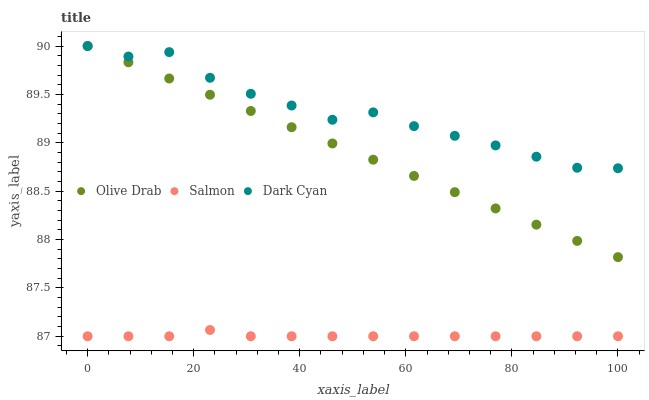Does Salmon have the minimum area under the curve?
Answer yes or no. Yes. Does Dark Cyan have the maximum area under the curve?
Answer yes or no. Yes. Does Olive Drab have the minimum area under the curve?
Answer yes or no. No. Does Olive Drab have the maximum area under the curve?
Answer yes or no. No. Is Olive Drab the smoothest?
Answer yes or no. Yes. Is Dark Cyan the roughest?
Answer yes or no. Yes. Is Salmon the smoothest?
Answer yes or no. No. Is Salmon the roughest?
Answer yes or no. No. Does Salmon have the lowest value?
Answer yes or no. Yes. Does Olive Drab have the lowest value?
Answer yes or no. No. Does Olive Drab have the highest value?
Answer yes or no. Yes. Does Salmon have the highest value?
Answer yes or no. No. Is Salmon less than Olive Drab?
Answer yes or no. Yes. Is Olive Drab greater than Salmon?
Answer yes or no. Yes. Does Olive Drab intersect Dark Cyan?
Answer yes or no. Yes. Is Olive Drab less than Dark Cyan?
Answer yes or no. No. Is Olive Drab greater than Dark Cyan?
Answer yes or no. No. Does Salmon intersect Olive Drab?
Answer yes or no. No. 